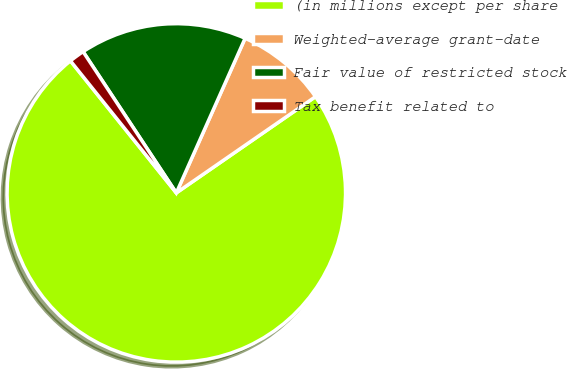<chart> <loc_0><loc_0><loc_500><loc_500><pie_chart><fcel>(in millions except per share<fcel>Weighted-average grant-date<fcel>Fair value of restricted stock<fcel>Tax benefit related to<nl><fcel>73.88%<fcel>8.71%<fcel>15.95%<fcel>1.47%<nl></chart> 